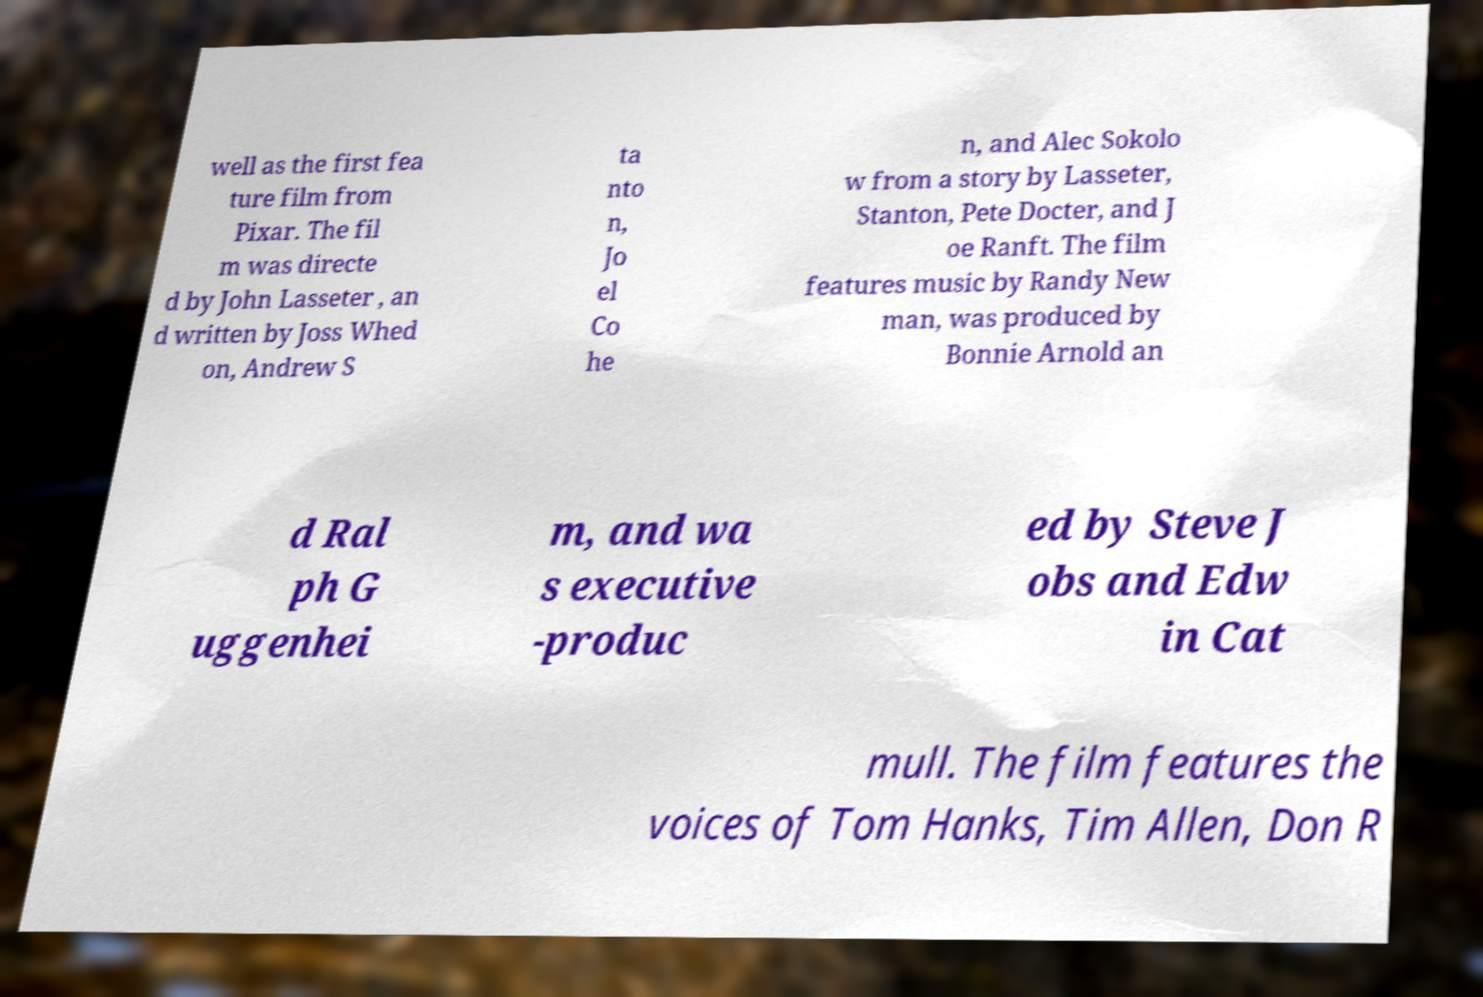Can you accurately transcribe the text from the provided image for me? well as the first fea ture film from Pixar. The fil m was directe d by John Lasseter , an d written by Joss Whed on, Andrew S ta nto n, Jo el Co he n, and Alec Sokolo w from a story by Lasseter, Stanton, Pete Docter, and J oe Ranft. The film features music by Randy New man, was produced by Bonnie Arnold an d Ral ph G uggenhei m, and wa s executive -produc ed by Steve J obs and Edw in Cat mull. The film features the voices of Tom Hanks, Tim Allen, Don R 